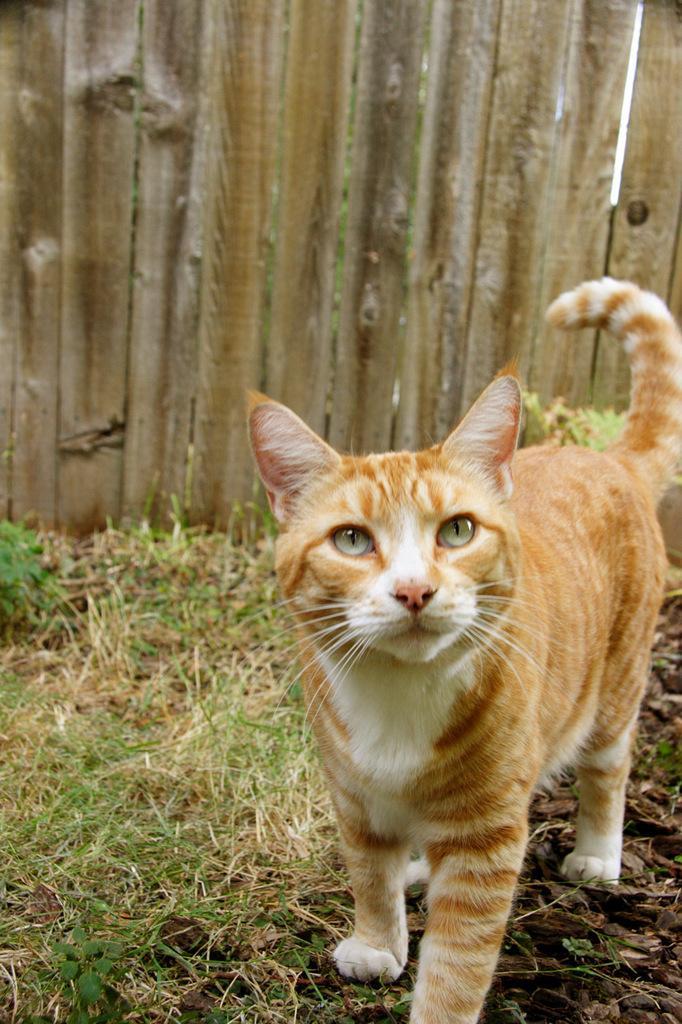Could you give a brief overview of what you see in this image? In this image there is a cat standing on the ground. There is grass on the ground. Behind it there is the wooden wall. 